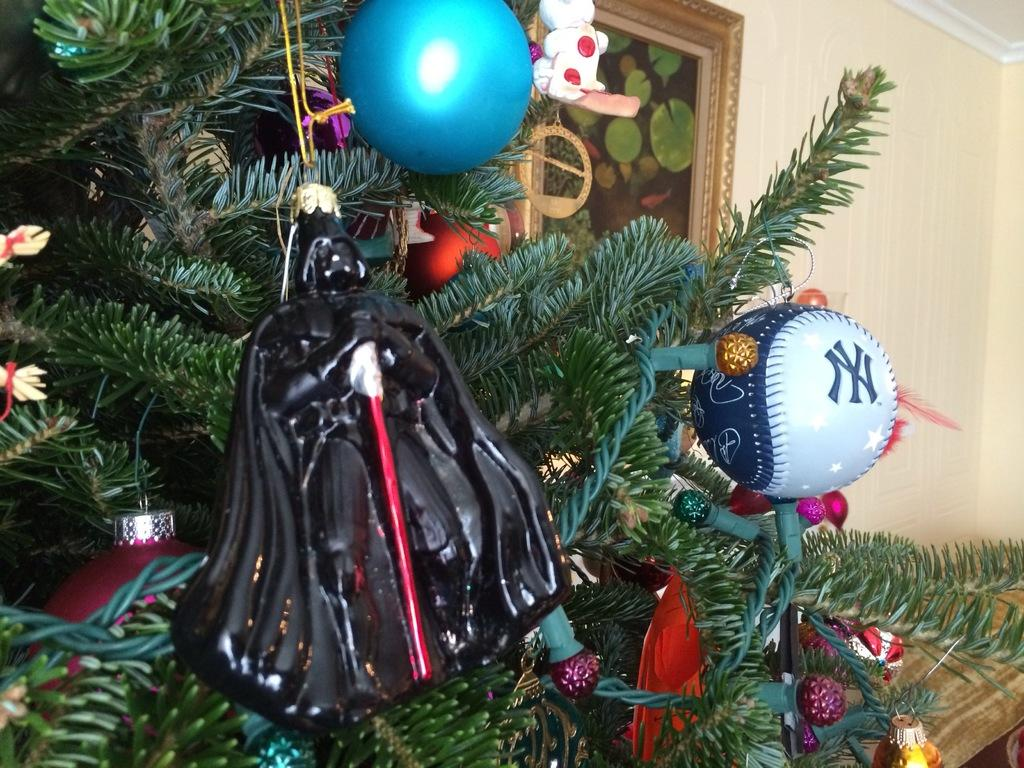What type of tree is in the image? There is a Christmas tree in the image. What decorations can be seen on the tree? There are balls in the image. What architectural feature is visible in the image? There is a window in the image. What other items are present in the image? There are toys in the image. What type of surface is visible in the image? There is a wall in the image. How many kittens are playing with the toys in the image? There are no kittens present in the image; it only features a Christmas tree, balls, a window, toys, and a wall. 